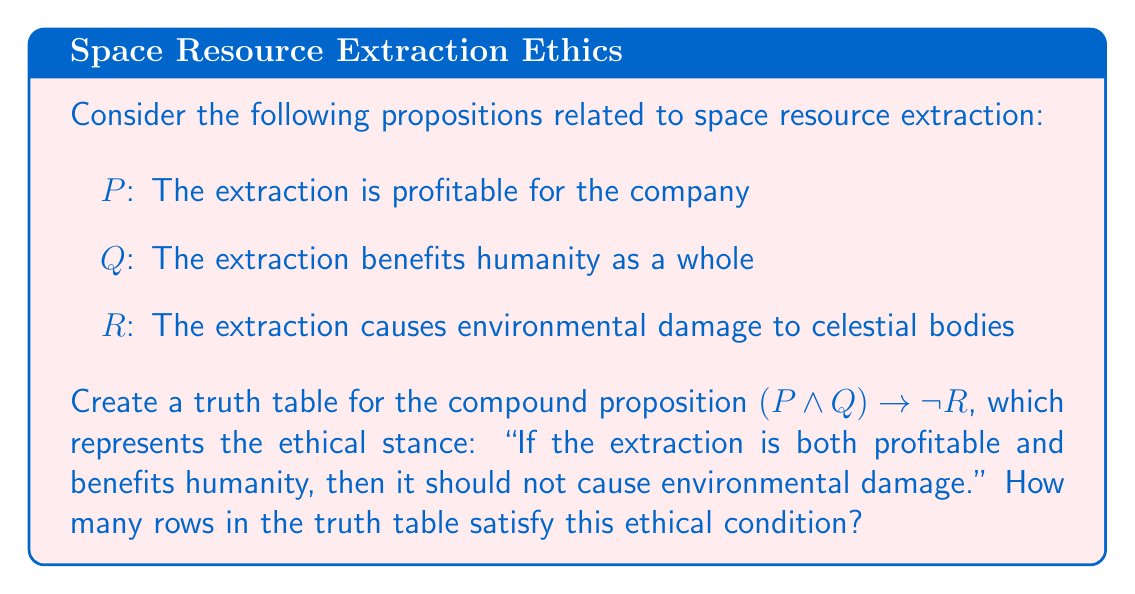What is the answer to this math problem? To solve this problem, we need to construct a truth table for the given compound proposition and count the number of rows where the proposition is true.

Step 1: Identify the atomic propositions
P: The extraction is profitable for the company
Q: The extraction benefits humanity as a whole
R: The extraction causes environmental damage to celestial bodies

Step 2: Construct the truth table
We need 8 rows (2^3) to cover all possible combinations of P, Q, and R.

$$
\begin{array}{|c|c|c|c|c|c|}
\hline
P & Q & R & P \land Q & \neg R & (P \land Q) \rightarrow \neg R \\
\hline
T & T & T & T & F & F \\
T & T & F & T & T & T \\
T & F & T & F & F & T \\
T & F & F & F & T & T \\
F & T & T & F & F & T \\
F & T & F & F & T & T \\
F & F & T & F & F & T \\
F & F & F & F & T & T \\
\hline
\end{array}
$$

Step 3: Evaluate $(P \land Q) \rightarrow \neg R$ for each row
- For the first row: $T \rightarrow F$ is false
- For all other rows: The implication is true

Step 4: Count the number of rows that satisfy the ethical condition
There are 7 rows where the compound proposition is true, satisfying the ethical condition.
Answer: 7 